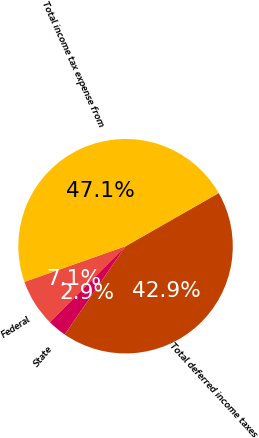Convert chart to OTSL. <chart><loc_0><loc_0><loc_500><loc_500><pie_chart><fcel>Federal<fcel>State<fcel>Total deferred income taxes<fcel>Total income tax expense from<nl><fcel>7.14%<fcel>2.86%<fcel>42.86%<fcel>47.14%<nl></chart> 